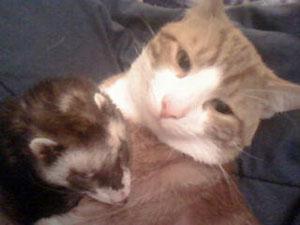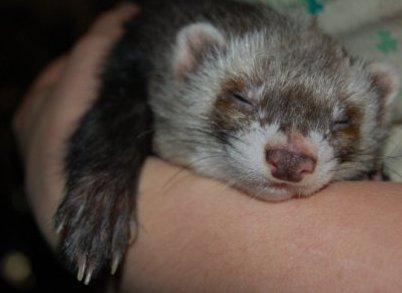The first image is the image on the left, the second image is the image on the right. Examine the images to the left and right. Is the description "The left image includes at least one ferret standing on all fours, and the right image contains two side-by-side ferrets with at least one having sleepy eyes." accurate? Answer yes or no. No. 